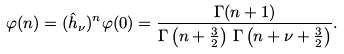Convert formula to latex. <formula><loc_0><loc_0><loc_500><loc_500>\varphi ( n ) = ( \hat { h } _ { \nu } ) ^ { n } \varphi ( 0 ) = \frac { \Gamma ( n + 1 ) } { \Gamma \left ( n + \frac { 3 } { 2 } \right ) \, \Gamma \left ( n + \nu + \frac { 3 } { 2 } \right ) } .</formula> 